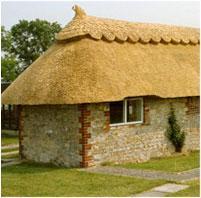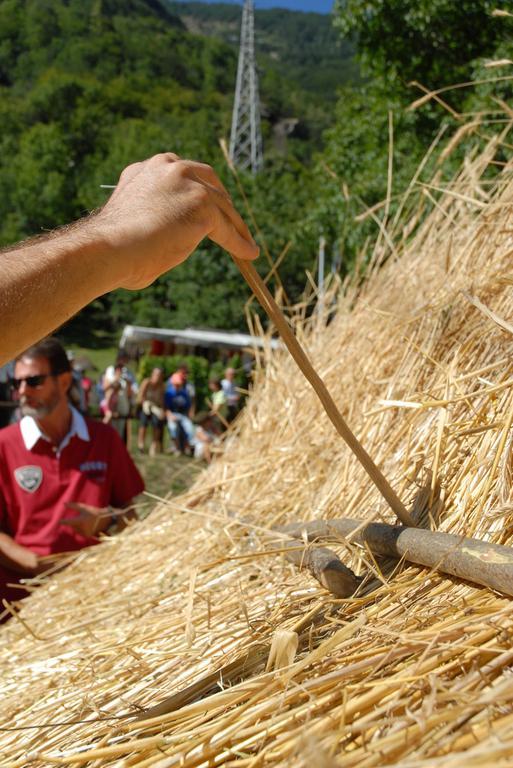The first image is the image on the left, the second image is the image on the right. For the images shown, is this caption "There are flowers by the house in one image, and a stone wall by the house in the other image." true? Answer yes or no. No. 